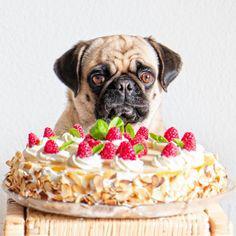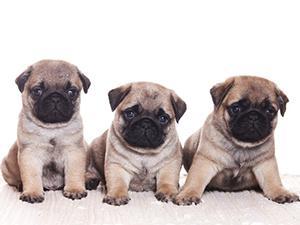The first image is the image on the left, the second image is the image on the right. For the images displayed, is the sentence "The right image contains three pug dogs." factually correct? Answer yes or no. Yes. The first image is the image on the left, the second image is the image on the right. Evaluate the accuracy of this statement regarding the images: "All dogs shown are buff-beige pugs with closed mouths, and one pug is pictured with a cake image by its face.". Is it true? Answer yes or no. Yes. 